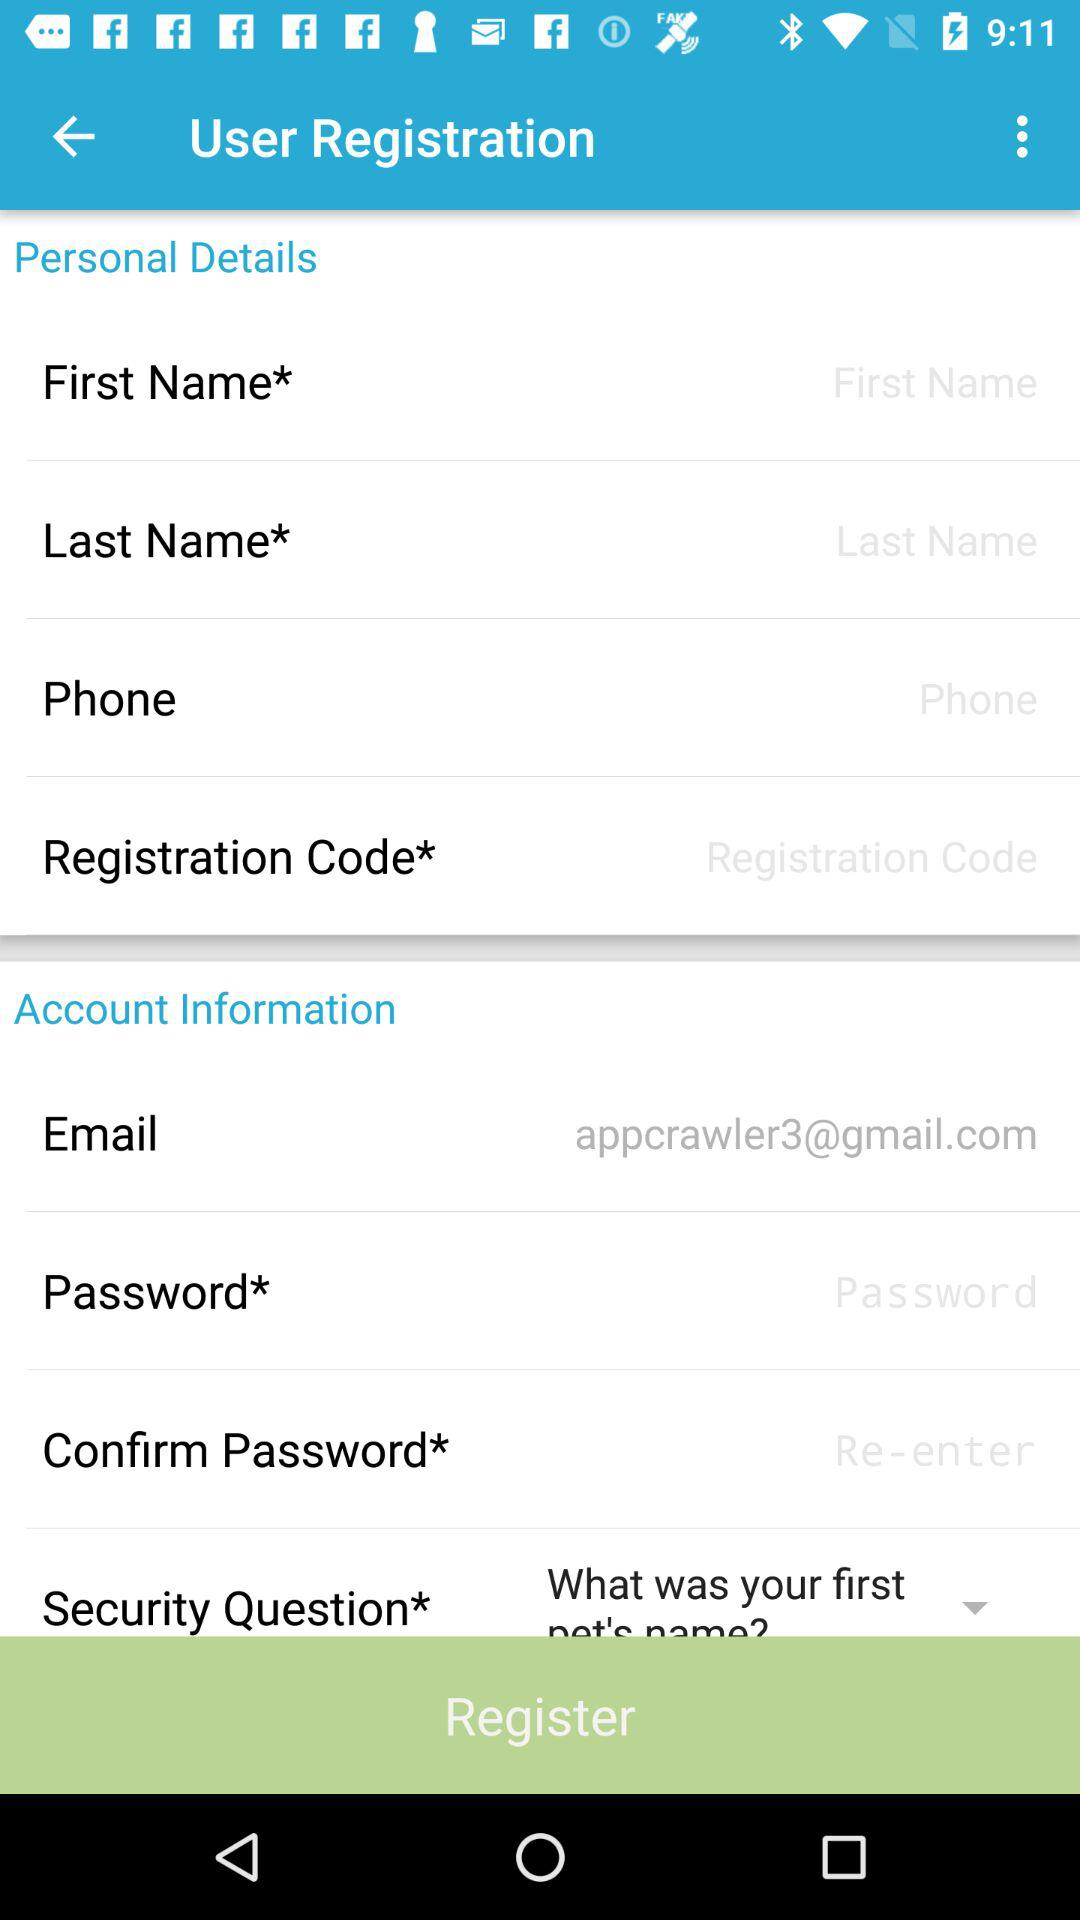What's the email address? The email address is appcrawler3@gmail.com. 